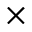Convert formula to latex. <formula><loc_0><loc_0><loc_500><loc_500>\times</formula> 